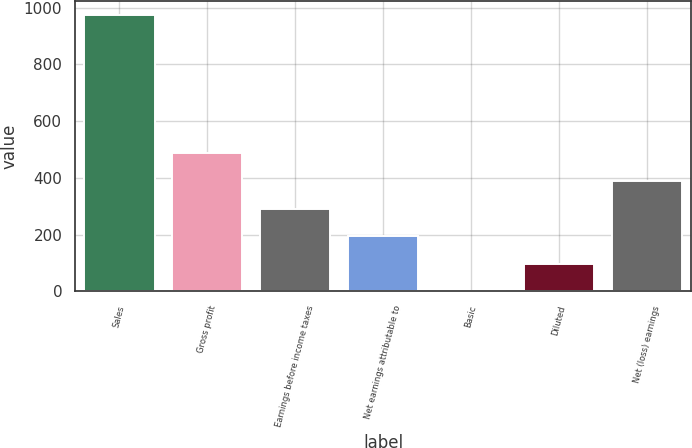Convert chart. <chart><loc_0><loc_0><loc_500><loc_500><bar_chart><fcel>Sales<fcel>Gross profit<fcel>Earnings before income taxes<fcel>Net earnings attributable to<fcel>Basic<fcel>Diluted<fcel>Net (loss) earnings<nl><fcel>973.1<fcel>486.6<fcel>292<fcel>194.7<fcel>0.1<fcel>97.4<fcel>389.3<nl></chart> 